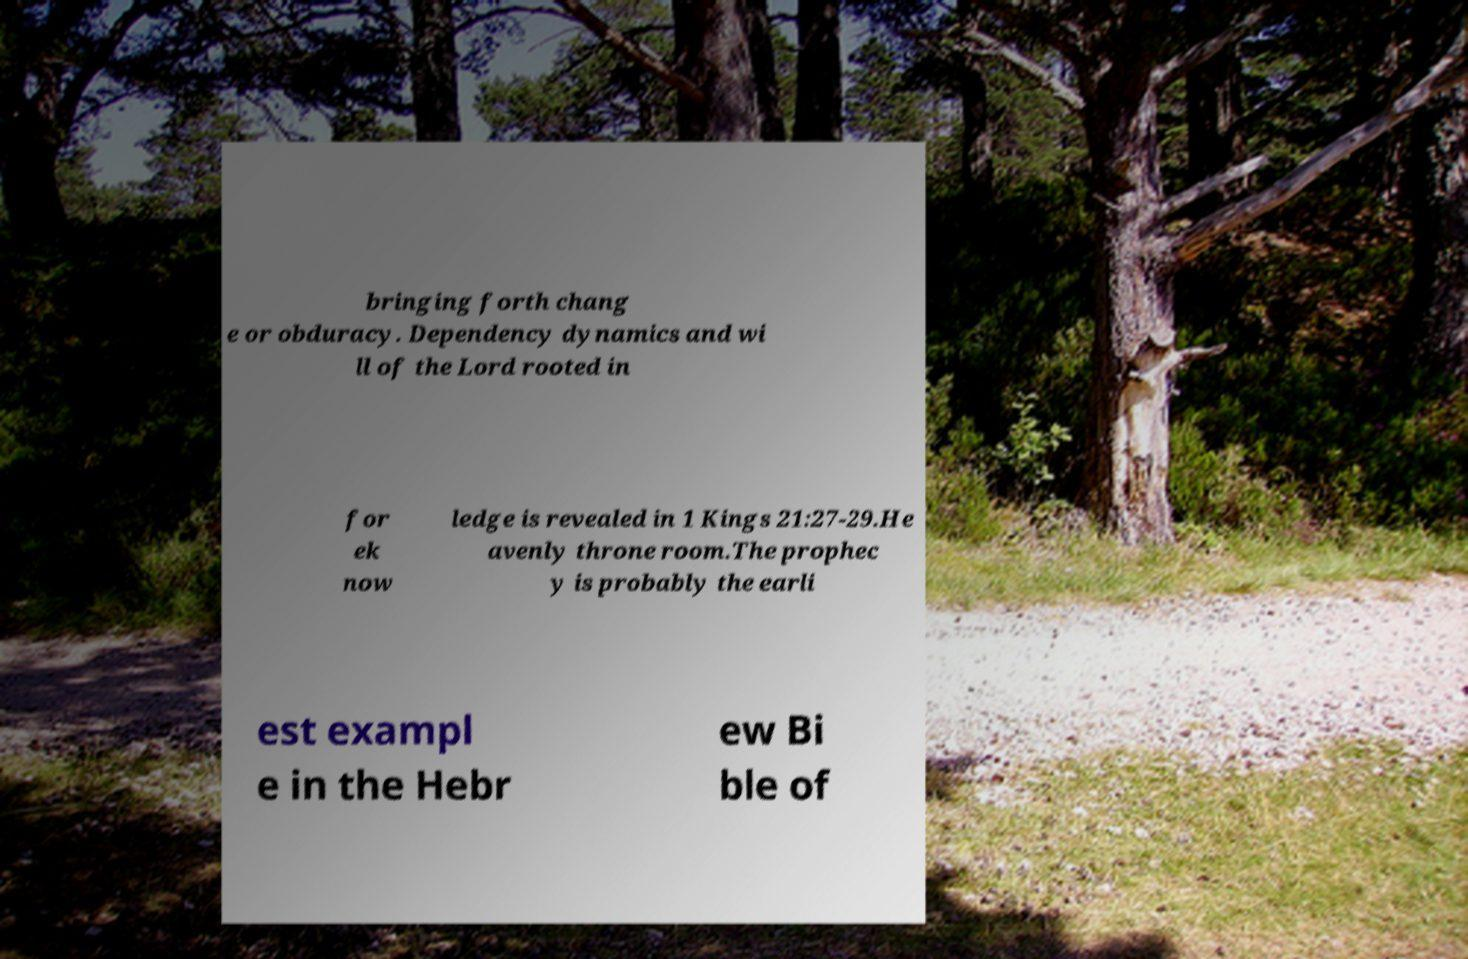Could you extract and type out the text from this image? bringing forth chang e or obduracy. Dependency dynamics and wi ll of the Lord rooted in for ek now ledge is revealed in 1 Kings 21:27-29.He avenly throne room.The prophec y is probably the earli est exampl e in the Hebr ew Bi ble of 